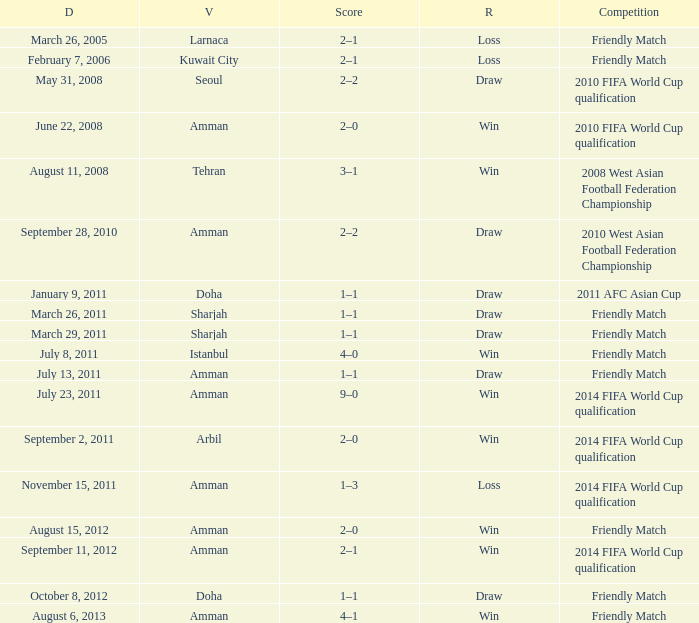WHat was the result of the friendly match that was played on october 8, 2012? Draw. 